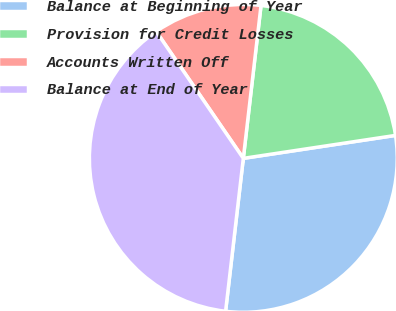Convert chart. <chart><loc_0><loc_0><loc_500><loc_500><pie_chart><fcel>Balance at Beginning of Year<fcel>Provision for Credit Losses<fcel>Accounts Written Off<fcel>Balance at End of Year<nl><fcel>29.22%<fcel>20.78%<fcel>11.41%<fcel>38.59%<nl></chart> 